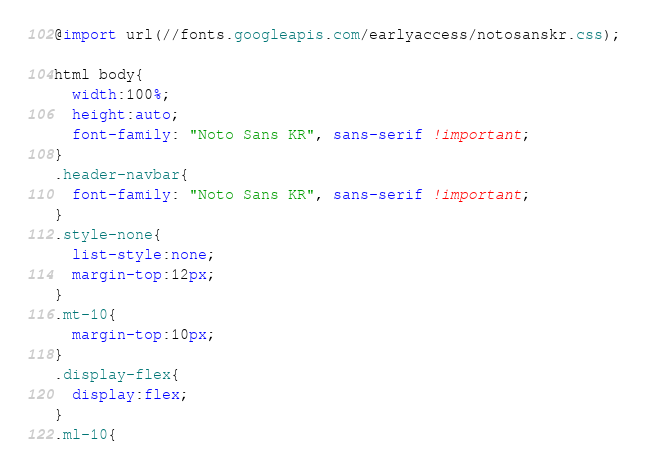Convert code to text. <code><loc_0><loc_0><loc_500><loc_500><_CSS_>@import url(//fonts.googleapis.com/earlyaccess/notosanskr.css);

html body{
  width:100%;
  height:auto;
  font-family: "Noto Sans KR", sans-serif !important;
}
.header-navbar{
  font-family: "Noto Sans KR", sans-serif !important;
}
.style-none{
  list-style:none;
  margin-top:12px;
}
.mt-10{
  margin-top:10px;
}
.display-flex{
  display:flex;
}
.ml-10{</code> 